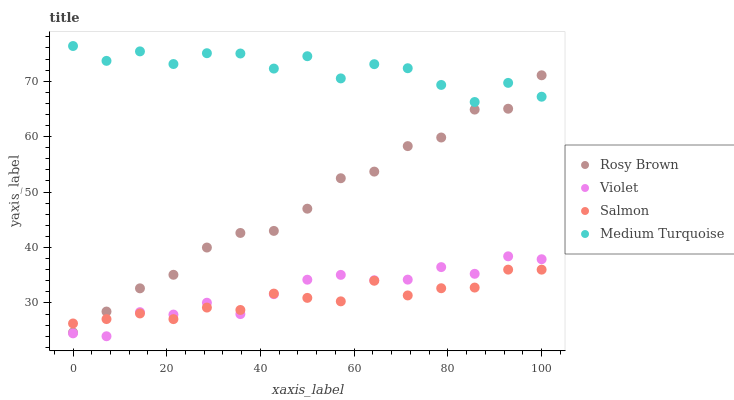Does Salmon have the minimum area under the curve?
Answer yes or no. Yes. Does Medium Turquoise have the maximum area under the curve?
Answer yes or no. Yes. Does Medium Turquoise have the minimum area under the curve?
Answer yes or no. No. Does Salmon have the maximum area under the curve?
Answer yes or no. No. Is Salmon the smoothest?
Answer yes or no. Yes. Is Medium Turquoise the roughest?
Answer yes or no. Yes. Is Medium Turquoise the smoothest?
Answer yes or no. No. Is Salmon the roughest?
Answer yes or no. No. Does Violet have the lowest value?
Answer yes or no. Yes. Does Salmon have the lowest value?
Answer yes or no. No. Does Medium Turquoise have the highest value?
Answer yes or no. Yes. Does Salmon have the highest value?
Answer yes or no. No. Is Violet less than Medium Turquoise?
Answer yes or no. Yes. Is Medium Turquoise greater than Salmon?
Answer yes or no. Yes. Does Rosy Brown intersect Medium Turquoise?
Answer yes or no. Yes. Is Rosy Brown less than Medium Turquoise?
Answer yes or no. No. Is Rosy Brown greater than Medium Turquoise?
Answer yes or no. No. Does Violet intersect Medium Turquoise?
Answer yes or no. No. 